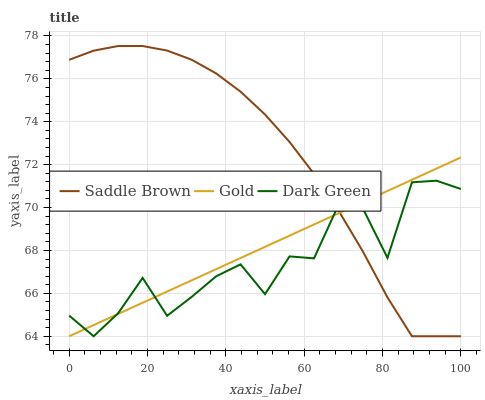Does Dark Green have the minimum area under the curve?
Answer yes or no. Yes. Does Gold have the minimum area under the curve?
Answer yes or no. No. Does Gold have the maximum area under the curve?
Answer yes or no. No. Is Dark Green the smoothest?
Answer yes or no. No. Is Gold the roughest?
Answer yes or no. No. Does Gold have the highest value?
Answer yes or no. No. 